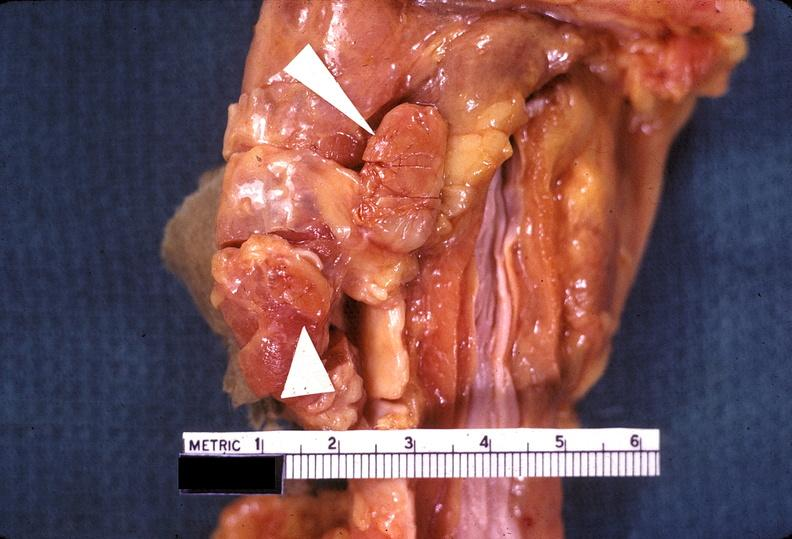does this image show parathyroid hyperplasia?
Answer the question using a single word or phrase. Yes 